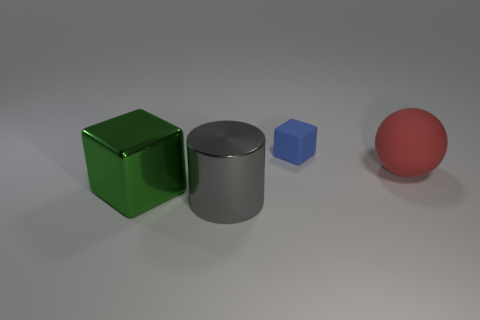Subtract 1 blocks. How many blocks are left? 1 Add 2 red objects. How many objects exist? 6 Subtract all green cubes. How many cubes are left? 1 Subtract 0 yellow blocks. How many objects are left? 4 Subtract all spheres. How many objects are left? 3 Subtract all gray balls. Subtract all brown blocks. How many balls are left? 1 Subtract all purple cylinders. How many blue cubes are left? 1 Subtract all gray rubber blocks. Subtract all tiny rubber things. How many objects are left? 3 Add 2 gray things. How many gray things are left? 3 Add 4 green shiny blocks. How many green shiny blocks exist? 5 